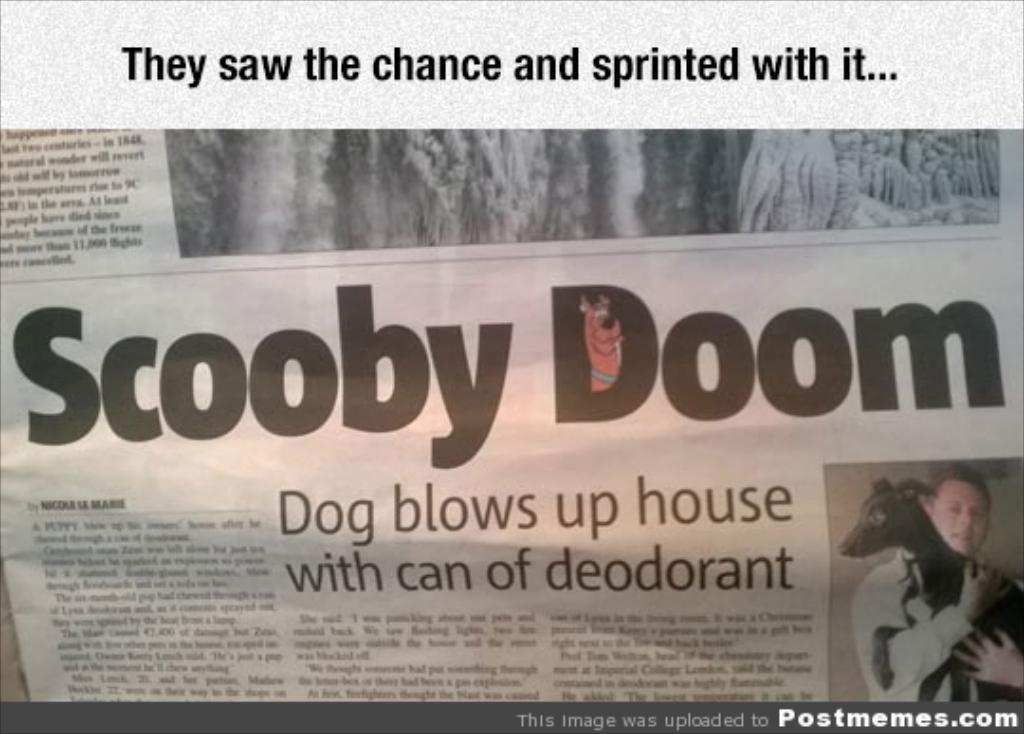In one or two sentences, can you explain what this image depicts? In the image in the center we can see one newspaper. On the newspaper,we can see one person holding dog. And we can see something written on the newspaper. 